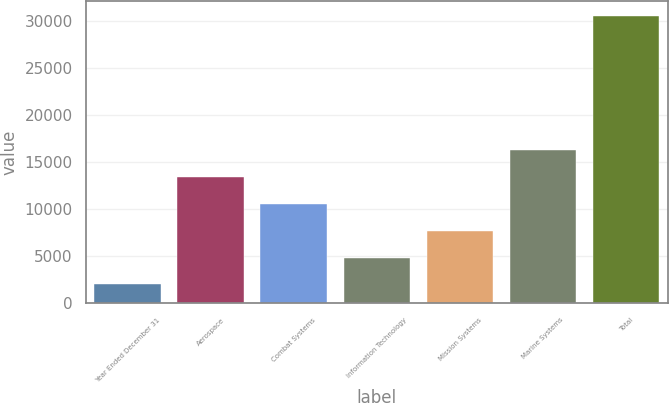<chart> <loc_0><loc_0><loc_500><loc_500><bar_chart><fcel>Year Ended December 31<fcel>Aerospace<fcel>Combat Systems<fcel>Information Technology<fcel>Mission Systems<fcel>Marine Systems<fcel>Total<nl><fcel>2016<fcel>13434<fcel>10579.5<fcel>4870.5<fcel>7725<fcel>16288.5<fcel>30561<nl></chart> 